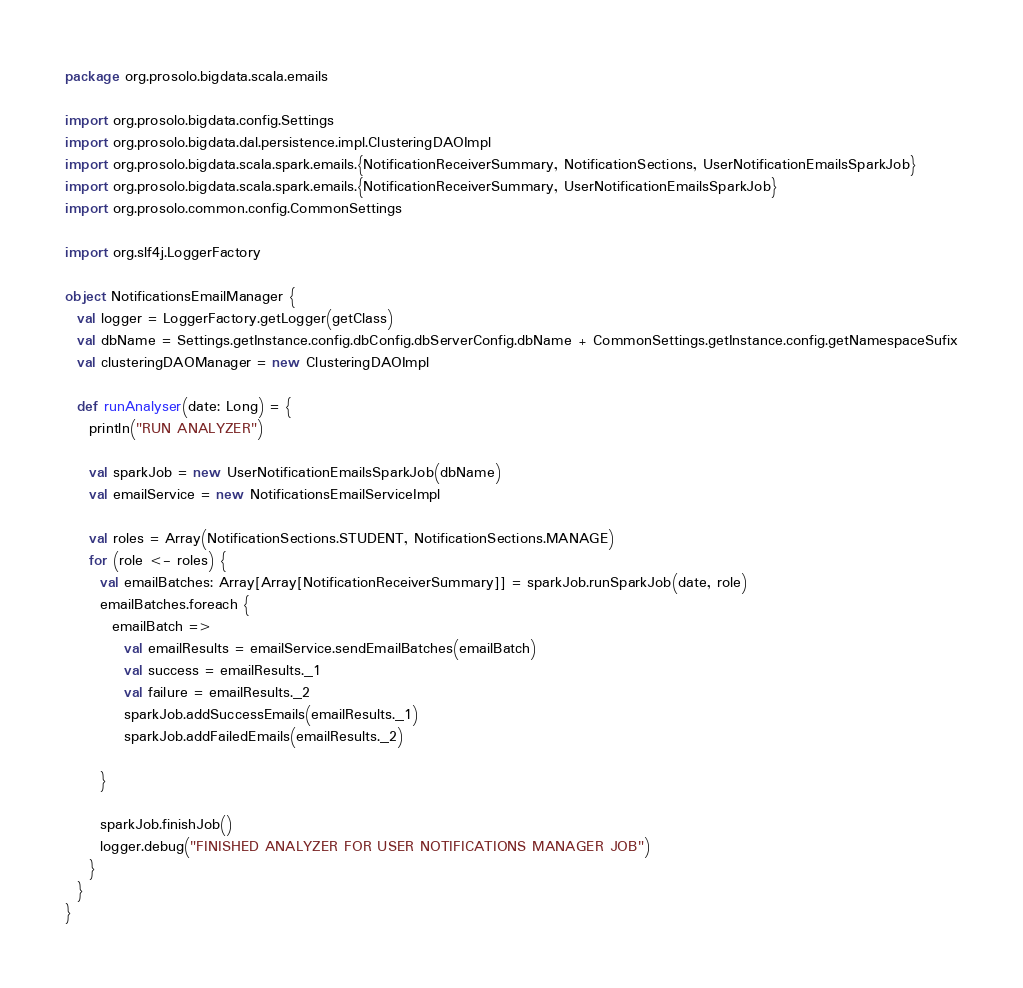<code> <loc_0><loc_0><loc_500><loc_500><_Scala_>package org.prosolo.bigdata.scala.emails

import org.prosolo.bigdata.config.Settings
import org.prosolo.bigdata.dal.persistence.impl.ClusteringDAOImpl
import org.prosolo.bigdata.scala.spark.emails.{NotificationReceiverSummary, NotificationSections, UserNotificationEmailsSparkJob}
import org.prosolo.bigdata.scala.spark.emails.{NotificationReceiverSummary, UserNotificationEmailsSparkJob}
import org.prosolo.common.config.CommonSettings

import org.slf4j.LoggerFactory

object NotificationsEmailManager {
  val logger = LoggerFactory.getLogger(getClass)
  val dbName = Settings.getInstance.config.dbConfig.dbServerConfig.dbName + CommonSettings.getInstance.config.getNamespaceSufix
  val clusteringDAOManager = new ClusteringDAOImpl

  def runAnalyser(date: Long) = {
    println("RUN ANALYZER")

    val sparkJob = new UserNotificationEmailsSparkJob(dbName)
    val emailService = new NotificationsEmailServiceImpl

    val roles = Array(NotificationSections.STUDENT, NotificationSections.MANAGE)
    for (role <- roles) {
      val emailBatches: Array[Array[NotificationReceiverSummary]] = sparkJob.runSparkJob(date, role)
      emailBatches.foreach {
        emailBatch =>
          val emailResults = emailService.sendEmailBatches(emailBatch)
          val success = emailResults._1
          val failure = emailResults._2
          sparkJob.addSuccessEmails(emailResults._1)
          sparkJob.addFailedEmails(emailResults._2)

      }

      sparkJob.finishJob()
      logger.debug("FINISHED ANALYZER FOR USER NOTIFICATIONS MANAGER JOB")
    }
  }
}
</code> 